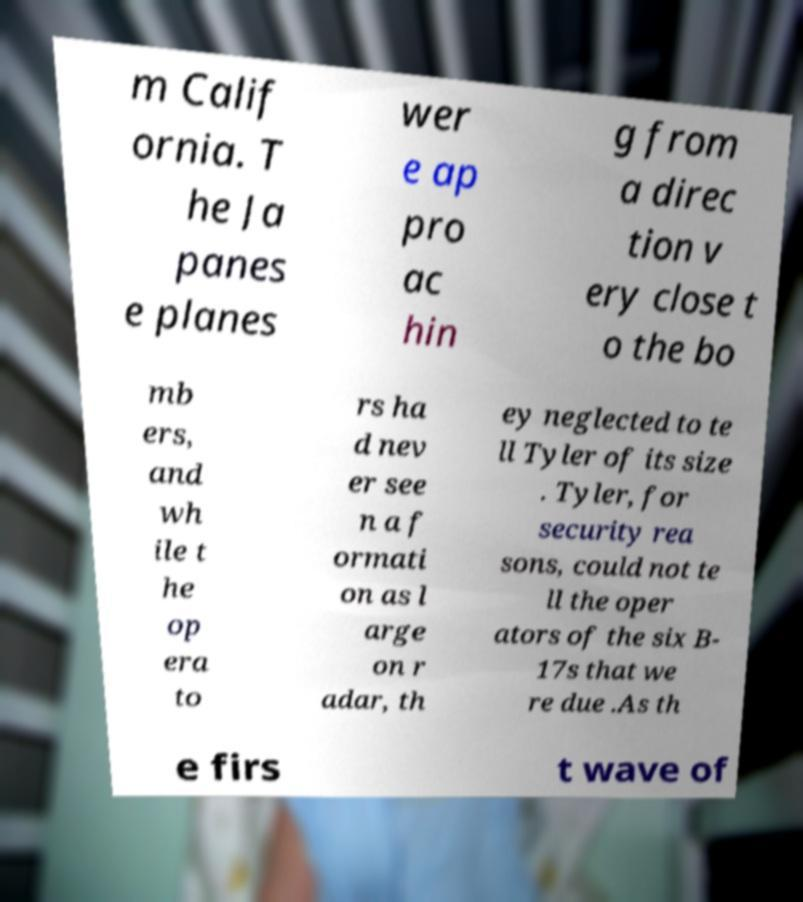There's text embedded in this image that I need extracted. Can you transcribe it verbatim? m Calif ornia. T he Ja panes e planes wer e ap pro ac hin g from a direc tion v ery close t o the bo mb ers, and wh ile t he op era to rs ha d nev er see n a f ormati on as l arge on r adar, th ey neglected to te ll Tyler of its size . Tyler, for security rea sons, could not te ll the oper ators of the six B- 17s that we re due .As th e firs t wave of 